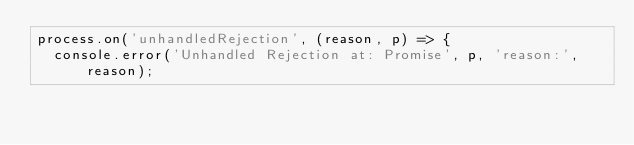<code> <loc_0><loc_0><loc_500><loc_500><_JavaScript_>process.on('unhandledRejection', (reason, p) => {
  console.error('Unhandled Rejection at: Promise', p, 'reason:', reason);</code> 